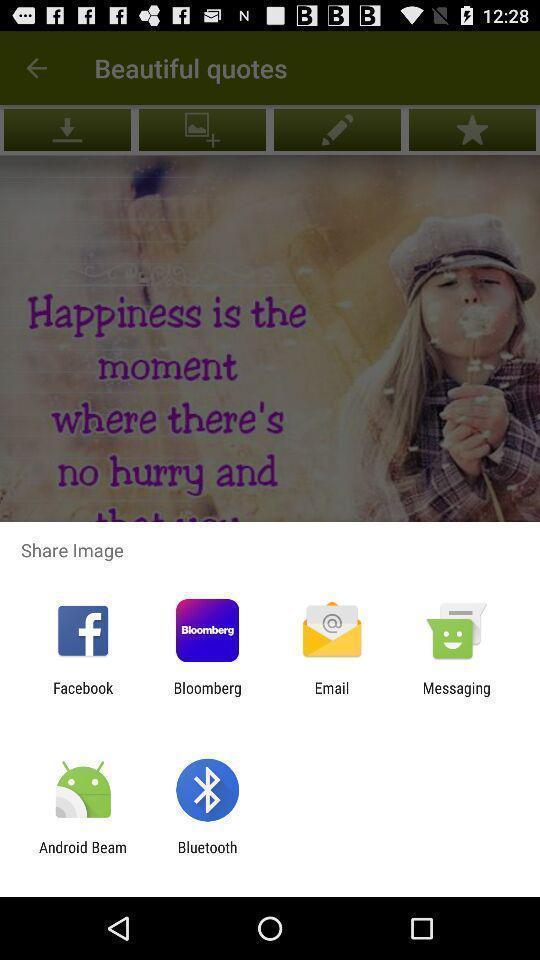Provide a textual representation of this image. Pop up displaying various apps. 